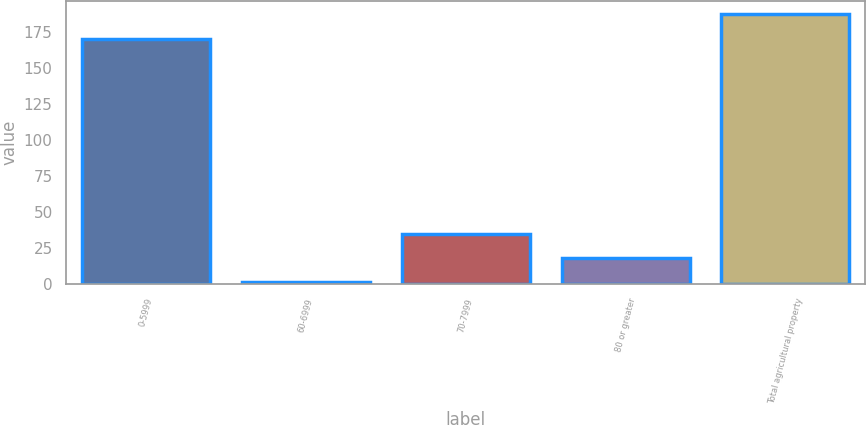Convert chart to OTSL. <chart><loc_0><loc_0><loc_500><loc_500><bar_chart><fcel>0-5999<fcel>60-6999<fcel>70-7999<fcel>80 or greater<fcel>Total agricultural property<nl><fcel>170<fcel>1.14<fcel>34.92<fcel>18.03<fcel>186.89<nl></chart> 